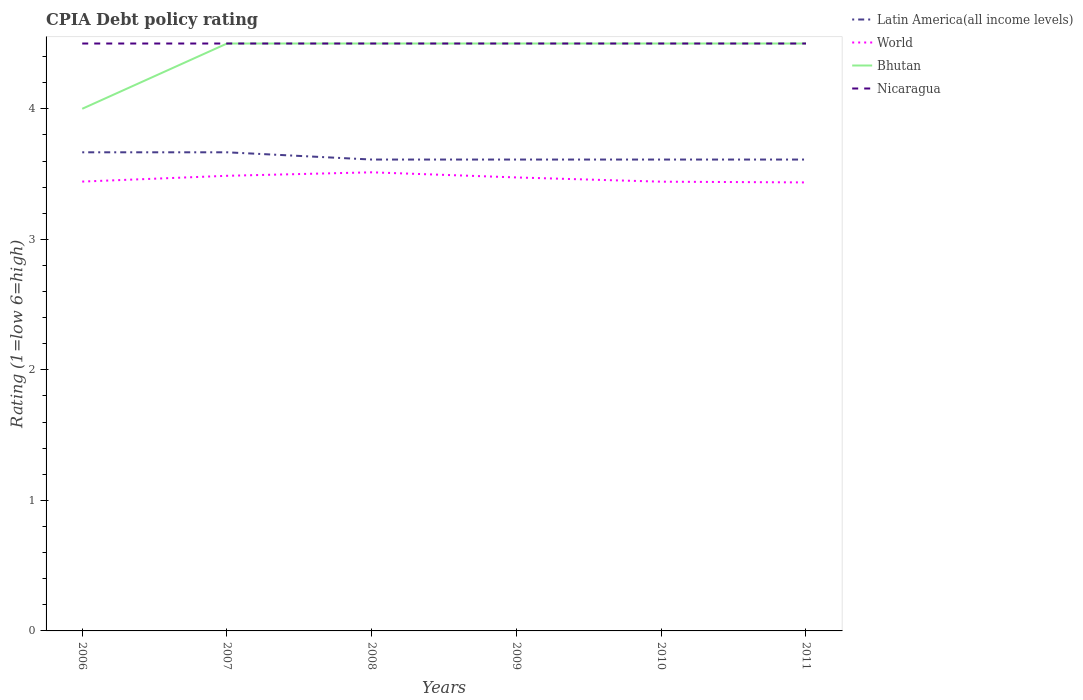Across all years, what is the maximum CPIA rating in Latin America(all income levels)?
Offer a terse response. 3.61. Is the CPIA rating in Latin America(all income levels) strictly greater than the CPIA rating in World over the years?
Keep it short and to the point. No. Does the graph contain any zero values?
Keep it short and to the point. No. How many legend labels are there?
Offer a very short reply. 4. How are the legend labels stacked?
Make the answer very short. Vertical. What is the title of the graph?
Offer a terse response. CPIA Debt policy rating. Does "Puerto Rico" appear as one of the legend labels in the graph?
Your answer should be compact. No. What is the label or title of the Y-axis?
Make the answer very short. Rating (1=low 6=high). What is the Rating (1=low 6=high) of Latin America(all income levels) in 2006?
Offer a very short reply. 3.67. What is the Rating (1=low 6=high) in World in 2006?
Make the answer very short. 3.44. What is the Rating (1=low 6=high) of Latin America(all income levels) in 2007?
Your answer should be very brief. 3.67. What is the Rating (1=low 6=high) in World in 2007?
Offer a terse response. 3.49. What is the Rating (1=low 6=high) of Bhutan in 2007?
Your response must be concise. 4.5. What is the Rating (1=low 6=high) of Nicaragua in 2007?
Your answer should be compact. 4.5. What is the Rating (1=low 6=high) in Latin America(all income levels) in 2008?
Your response must be concise. 3.61. What is the Rating (1=low 6=high) in World in 2008?
Offer a terse response. 3.51. What is the Rating (1=low 6=high) in Bhutan in 2008?
Offer a terse response. 4.5. What is the Rating (1=low 6=high) of Latin America(all income levels) in 2009?
Give a very brief answer. 3.61. What is the Rating (1=low 6=high) in World in 2009?
Your answer should be very brief. 3.47. What is the Rating (1=low 6=high) of Latin America(all income levels) in 2010?
Your answer should be compact. 3.61. What is the Rating (1=low 6=high) of World in 2010?
Your answer should be very brief. 3.44. What is the Rating (1=low 6=high) of Bhutan in 2010?
Keep it short and to the point. 4.5. What is the Rating (1=low 6=high) in Nicaragua in 2010?
Make the answer very short. 4.5. What is the Rating (1=low 6=high) of Latin America(all income levels) in 2011?
Give a very brief answer. 3.61. What is the Rating (1=low 6=high) of World in 2011?
Keep it short and to the point. 3.44. What is the Rating (1=low 6=high) of Bhutan in 2011?
Offer a very short reply. 4.5. What is the Rating (1=low 6=high) in Nicaragua in 2011?
Ensure brevity in your answer.  4.5. Across all years, what is the maximum Rating (1=low 6=high) of Latin America(all income levels)?
Give a very brief answer. 3.67. Across all years, what is the maximum Rating (1=low 6=high) in World?
Your response must be concise. 3.51. Across all years, what is the maximum Rating (1=low 6=high) of Bhutan?
Your answer should be very brief. 4.5. Across all years, what is the maximum Rating (1=low 6=high) of Nicaragua?
Offer a very short reply. 4.5. Across all years, what is the minimum Rating (1=low 6=high) in Latin America(all income levels)?
Provide a short and direct response. 3.61. Across all years, what is the minimum Rating (1=low 6=high) of World?
Your response must be concise. 3.44. Across all years, what is the minimum Rating (1=low 6=high) of Nicaragua?
Provide a succinct answer. 4.5. What is the total Rating (1=low 6=high) in Latin America(all income levels) in the graph?
Your answer should be very brief. 21.78. What is the total Rating (1=low 6=high) of World in the graph?
Make the answer very short. 20.79. What is the difference between the Rating (1=low 6=high) of Latin America(all income levels) in 2006 and that in 2007?
Your answer should be very brief. 0. What is the difference between the Rating (1=low 6=high) of World in 2006 and that in 2007?
Offer a very short reply. -0.04. What is the difference between the Rating (1=low 6=high) of Latin America(all income levels) in 2006 and that in 2008?
Provide a short and direct response. 0.06. What is the difference between the Rating (1=low 6=high) of World in 2006 and that in 2008?
Keep it short and to the point. -0.07. What is the difference between the Rating (1=low 6=high) in Nicaragua in 2006 and that in 2008?
Offer a very short reply. 0. What is the difference between the Rating (1=low 6=high) of Latin America(all income levels) in 2006 and that in 2009?
Your answer should be very brief. 0.06. What is the difference between the Rating (1=low 6=high) of World in 2006 and that in 2009?
Ensure brevity in your answer.  -0.03. What is the difference between the Rating (1=low 6=high) of Bhutan in 2006 and that in 2009?
Offer a terse response. -0.5. What is the difference between the Rating (1=low 6=high) of Nicaragua in 2006 and that in 2009?
Make the answer very short. 0. What is the difference between the Rating (1=low 6=high) in Latin America(all income levels) in 2006 and that in 2010?
Offer a terse response. 0.06. What is the difference between the Rating (1=low 6=high) in World in 2006 and that in 2010?
Your answer should be very brief. 0. What is the difference between the Rating (1=low 6=high) of Latin America(all income levels) in 2006 and that in 2011?
Offer a terse response. 0.06. What is the difference between the Rating (1=low 6=high) in World in 2006 and that in 2011?
Keep it short and to the point. 0.01. What is the difference between the Rating (1=low 6=high) of Latin America(all income levels) in 2007 and that in 2008?
Provide a succinct answer. 0.06. What is the difference between the Rating (1=low 6=high) in World in 2007 and that in 2008?
Give a very brief answer. -0.03. What is the difference between the Rating (1=low 6=high) of Bhutan in 2007 and that in 2008?
Your answer should be very brief. 0. What is the difference between the Rating (1=low 6=high) of Latin America(all income levels) in 2007 and that in 2009?
Make the answer very short. 0.06. What is the difference between the Rating (1=low 6=high) in World in 2007 and that in 2009?
Your response must be concise. 0.01. What is the difference between the Rating (1=low 6=high) of Bhutan in 2007 and that in 2009?
Make the answer very short. 0. What is the difference between the Rating (1=low 6=high) of Latin America(all income levels) in 2007 and that in 2010?
Ensure brevity in your answer.  0.06. What is the difference between the Rating (1=low 6=high) in World in 2007 and that in 2010?
Make the answer very short. 0.05. What is the difference between the Rating (1=low 6=high) in Nicaragua in 2007 and that in 2010?
Your answer should be compact. 0. What is the difference between the Rating (1=low 6=high) in Latin America(all income levels) in 2007 and that in 2011?
Your answer should be compact. 0.06. What is the difference between the Rating (1=low 6=high) of World in 2007 and that in 2011?
Make the answer very short. 0.05. What is the difference between the Rating (1=low 6=high) of Bhutan in 2007 and that in 2011?
Provide a succinct answer. 0. What is the difference between the Rating (1=low 6=high) of Nicaragua in 2007 and that in 2011?
Your response must be concise. 0. What is the difference between the Rating (1=low 6=high) of World in 2008 and that in 2009?
Your answer should be compact. 0.04. What is the difference between the Rating (1=low 6=high) in Bhutan in 2008 and that in 2009?
Your response must be concise. 0. What is the difference between the Rating (1=low 6=high) in Latin America(all income levels) in 2008 and that in 2010?
Ensure brevity in your answer.  0. What is the difference between the Rating (1=low 6=high) in World in 2008 and that in 2010?
Keep it short and to the point. 0.07. What is the difference between the Rating (1=low 6=high) in Bhutan in 2008 and that in 2010?
Your answer should be very brief. 0. What is the difference between the Rating (1=low 6=high) of Latin America(all income levels) in 2008 and that in 2011?
Your response must be concise. 0. What is the difference between the Rating (1=low 6=high) of World in 2008 and that in 2011?
Give a very brief answer. 0.08. What is the difference between the Rating (1=low 6=high) of Nicaragua in 2008 and that in 2011?
Give a very brief answer. 0. What is the difference between the Rating (1=low 6=high) of Latin America(all income levels) in 2009 and that in 2010?
Provide a succinct answer. 0. What is the difference between the Rating (1=low 6=high) of World in 2009 and that in 2010?
Provide a short and direct response. 0.03. What is the difference between the Rating (1=low 6=high) of Latin America(all income levels) in 2009 and that in 2011?
Give a very brief answer. 0. What is the difference between the Rating (1=low 6=high) in World in 2009 and that in 2011?
Your answer should be compact. 0.04. What is the difference between the Rating (1=low 6=high) of Nicaragua in 2009 and that in 2011?
Provide a short and direct response. 0. What is the difference between the Rating (1=low 6=high) of World in 2010 and that in 2011?
Your answer should be very brief. 0.01. What is the difference between the Rating (1=low 6=high) of Bhutan in 2010 and that in 2011?
Offer a very short reply. 0. What is the difference between the Rating (1=low 6=high) of Latin America(all income levels) in 2006 and the Rating (1=low 6=high) of World in 2007?
Offer a terse response. 0.18. What is the difference between the Rating (1=low 6=high) of Latin America(all income levels) in 2006 and the Rating (1=low 6=high) of Bhutan in 2007?
Give a very brief answer. -0.83. What is the difference between the Rating (1=low 6=high) of World in 2006 and the Rating (1=low 6=high) of Bhutan in 2007?
Ensure brevity in your answer.  -1.06. What is the difference between the Rating (1=low 6=high) of World in 2006 and the Rating (1=low 6=high) of Nicaragua in 2007?
Your answer should be very brief. -1.06. What is the difference between the Rating (1=low 6=high) of Bhutan in 2006 and the Rating (1=low 6=high) of Nicaragua in 2007?
Provide a short and direct response. -0.5. What is the difference between the Rating (1=low 6=high) in Latin America(all income levels) in 2006 and the Rating (1=low 6=high) in World in 2008?
Ensure brevity in your answer.  0.15. What is the difference between the Rating (1=low 6=high) in Latin America(all income levels) in 2006 and the Rating (1=low 6=high) in Bhutan in 2008?
Keep it short and to the point. -0.83. What is the difference between the Rating (1=low 6=high) of Latin America(all income levels) in 2006 and the Rating (1=low 6=high) of Nicaragua in 2008?
Ensure brevity in your answer.  -0.83. What is the difference between the Rating (1=low 6=high) of World in 2006 and the Rating (1=low 6=high) of Bhutan in 2008?
Offer a very short reply. -1.06. What is the difference between the Rating (1=low 6=high) in World in 2006 and the Rating (1=low 6=high) in Nicaragua in 2008?
Keep it short and to the point. -1.06. What is the difference between the Rating (1=low 6=high) of Bhutan in 2006 and the Rating (1=low 6=high) of Nicaragua in 2008?
Offer a terse response. -0.5. What is the difference between the Rating (1=low 6=high) in Latin America(all income levels) in 2006 and the Rating (1=low 6=high) in World in 2009?
Keep it short and to the point. 0.19. What is the difference between the Rating (1=low 6=high) of Latin America(all income levels) in 2006 and the Rating (1=low 6=high) of Nicaragua in 2009?
Your answer should be very brief. -0.83. What is the difference between the Rating (1=low 6=high) in World in 2006 and the Rating (1=low 6=high) in Bhutan in 2009?
Keep it short and to the point. -1.06. What is the difference between the Rating (1=low 6=high) in World in 2006 and the Rating (1=low 6=high) in Nicaragua in 2009?
Make the answer very short. -1.06. What is the difference between the Rating (1=low 6=high) in Bhutan in 2006 and the Rating (1=low 6=high) in Nicaragua in 2009?
Make the answer very short. -0.5. What is the difference between the Rating (1=low 6=high) in Latin America(all income levels) in 2006 and the Rating (1=low 6=high) in World in 2010?
Your answer should be compact. 0.23. What is the difference between the Rating (1=low 6=high) in Latin America(all income levels) in 2006 and the Rating (1=low 6=high) in Bhutan in 2010?
Offer a terse response. -0.83. What is the difference between the Rating (1=low 6=high) of Latin America(all income levels) in 2006 and the Rating (1=low 6=high) of Nicaragua in 2010?
Offer a very short reply. -0.83. What is the difference between the Rating (1=low 6=high) of World in 2006 and the Rating (1=low 6=high) of Bhutan in 2010?
Your response must be concise. -1.06. What is the difference between the Rating (1=low 6=high) of World in 2006 and the Rating (1=low 6=high) of Nicaragua in 2010?
Make the answer very short. -1.06. What is the difference between the Rating (1=low 6=high) of Latin America(all income levels) in 2006 and the Rating (1=low 6=high) of World in 2011?
Your answer should be very brief. 0.23. What is the difference between the Rating (1=low 6=high) in Latin America(all income levels) in 2006 and the Rating (1=low 6=high) in Bhutan in 2011?
Make the answer very short. -0.83. What is the difference between the Rating (1=low 6=high) of World in 2006 and the Rating (1=low 6=high) of Bhutan in 2011?
Your answer should be compact. -1.06. What is the difference between the Rating (1=low 6=high) of World in 2006 and the Rating (1=low 6=high) of Nicaragua in 2011?
Your response must be concise. -1.06. What is the difference between the Rating (1=low 6=high) in Latin America(all income levels) in 2007 and the Rating (1=low 6=high) in World in 2008?
Ensure brevity in your answer.  0.15. What is the difference between the Rating (1=low 6=high) in Latin America(all income levels) in 2007 and the Rating (1=low 6=high) in Bhutan in 2008?
Provide a succinct answer. -0.83. What is the difference between the Rating (1=low 6=high) in World in 2007 and the Rating (1=low 6=high) in Bhutan in 2008?
Your answer should be very brief. -1.01. What is the difference between the Rating (1=low 6=high) in World in 2007 and the Rating (1=low 6=high) in Nicaragua in 2008?
Ensure brevity in your answer.  -1.01. What is the difference between the Rating (1=low 6=high) in Bhutan in 2007 and the Rating (1=low 6=high) in Nicaragua in 2008?
Offer a terse response. 0. What is the difference between the Rating (1=low 6=high) of Latin America(all income levels) in 2007 and the Rating (1=low 6=high) of World in 2009?
Your answer should be very brief. 0.19. What is the difference between the Rating (1=low 6=high) in Latin America(all income levels) in 2007 and the Rating (1=low 6=high) in Nicaragua in 2009?
Make the answer very short. -0.83. What is the difference between the Rating (1=low 6=high) of World in 2007 and the Rating (1=low 6=high) of Bhutan in 2009?
Keep it short and to the point. -1.01. What is the difference between the Rating (1=low 6=high) in World in 2007 and the Rating (1=low 6=high) in Nicaragua in 2009?
Offer a terse response. -1.01. What is the difference between the Rating (1=low 6=high) of Bhutan in 2007 and the Rating (1=low 6=high) of Nicaragua in 2009?
Make the answer very short. 0. What is the difference between the Rating (1=low 6=high) of Latin America(all income levels) in 2007 and the Rating (1=low 6=high) of World in 2010?
Your answer should be very brief. 0.23. What is the difference between the Rating (1=low 6=high) in Latin America(all income levels) in 2007 and the Rating (1=low 6=high) in Bhutan in 2010?
Your response must be concise. -0.83. What is the difference between the Rating (1=low 6=high) in Latin America(all income levels) in 2007 and the Rating (1=low 6=high) in Nicaragua in 2010?
Your response must be concise. -0.83. What is the difference between the Rating (1=low 6=high) of World in 2007 and the Rating (1=low 6=high) of Bhutan in 2010?
Give a very brief answer. -1.01. What is the difference between the Rating (1=low 6=high) of World in 2007 and the Rating (1=low 6=high) of Nicaragua in 2010?
Offer a terse response. -1.01. What is the difference between the Rating (1=low 6=high) in Bhutan in 2007 and the Rating (1=low 6=high) in Nicaragua in 2010?
Offer a very short reply. 0. What is the difference between the Rating (1=low 6=high) in Latin America(all income levels) in 2007 and the Rating (1=low 6=high) in World in 2011?
Ensure brevity in your answer.  0.23. What is the difference between the Rating (1=low 6=high) of Latin America(all income levels) in 2007 and the Rating (1=low 6=high) of Bhutan in 2011?
Your answer should be very brief. -0.83. What is the difference between the Rating (1=low 6=high) of Latin America(all income levels) in 2007 and the Rating (1=low 6=high) of Nicaragua in 2011?
Provide a succinct answer. -0.83. What is the difference between the Rating (1=low 6=high) of World in 2007 and the Rating (1=low 6=high) of Bhutan in 2011?
Keep it short and to the point. -1.01. What is the difference between the Rating (1=low 6=high) of World in 2007 and the Rating (1=low 6=high) of Nicaragua in 2011?
Keep it short and to the point. -1.01. What is the difference between the Rating (1=low 6=high) in Latin America(all income levels) in 2008 and the Rating (1=low 6=high) in World in 2009?
Keep it short and to the point. 0.14. What is the difference between the Rating (1=low 6=high) of Latin America(all income levels) in 2008 and the Rating (1=low 6=high) of Bhutan in 2009?
Your response must be concise. -0.89. What is the difference between the Rating (1=low 6=high) in Latin America(all income levels) in 2008 and the Rating (1=low 6=high) in Nicaragua in 2009?
Your response must be concise. -0.89. What is the difference between the Rating (1=low 6=high) of World in 2008 and the Rating (1=low 6=high) of Bhutan in 2009?
Make the answer very short. -0.99. What is the difference between the Rating (1=low 6=high) in World in 2008 and the Rating (1=low 6=high) in Nicaragua in 2009?
Ensure brevity in your answer.  -0.99. What is the difference between the Rating (1=low 6=high) of Bhutan in 2008 and the Rating (1=low 6=high) of Nicaragua in 2009?
Ensure brevity in your answer.  0. What is the difference between the Rating (1=low 6=high) in Latin America(all income levels) in 2008 and the Rating (1=low 6=high) in World in 2010?
Offer a terse response. 0.17. What is the difference between the Rating (1=low 6=high) of Latin America(all income levels) in 2008 and the Rating (1=low 6=high) of Bhutan in 2010?
Make the answer very short. -0.89. What is the difference between the Rating (1=low 6=high) in Latin America(all income levels) in 2008 and the Rating (1=low 6=high) in Nicaragua in 2010?
Ensure brevity in your answer.  -0.89. What is the difference between the Rating (1=low 6=high) of World in 2008 and the Rating (1=low 6=high) of Bhutan in 2010?
Your answer should be compact. -0.99. What is the difference between the Rating (1=low 6=high) in World in 2008 and the Rating (1=low 6=high) in Nicaragua in 2010?
Offer a very short reply. -0.99. What is the difference between the Rating (1=low 6=high) of Bhutan in 2008 and the Rating (1=low 6=high) of Nicaragua in 2010?
Provide a short and direct response. 0. What is the difference between the Rating (1=low 6=high) of Latin America(all income levels) in 2008 and the Rating (1=low 6=high) of World in 2011?
Offer a terse response. 0.18. What is the difference between the Rating (1=low 6=high) in Latin America(all income levels) in 2008 and the Rating (1=low 6=high) in Bhutan in 2011?
Keep it short and to the point. -0.89. What is the difference between the Rating (1=low 6=high) of Latin America(all income levels) in 2008 and the Rating (1=low 6=high) of Nicaragua in 2011?
Ensure brevity in your answer.  -0.89. What is the difference between the Rating (1=low 6=high) in World in 2008 and the Rating (1=low 6=high) in Bhutan in 2011?
Your answer should be very brief. -0.99. What is the difference between the Rating (1=low 6=high) of World in 2008 and the Rating (1=low 6=high) of Nicaragua in 2011?
Make the answer very short. -0.99. What is the difference between the Rating (1=low 6=high) in Bhutan in 2008 and the Rating (1=low 6=high) in Nicaragua in 2011?
Make the answer very short. 0. What is the difference between the Rating (1=low 6=high) in Latin America(all income levels) in 2009 and the Rating (1=low 6=high) in World in 2010?
Make the answer very short. 0.17. What is the difference between the Rating (1=low 6=high) in Latin America(all income levels) in 2009 and the Rating (1=low 6=high) in Bhutan in 2010?
Make the answer very short. -0.89. What is the difference between the Rating (1=low 6=high) of Latin America(all income levels) in 2009 and the Rating (1=low 6=high) of Nicaragua in 2010?
Keep it short and to the point. -0.89. What is the difference between the Rating (1=low 6=high) of World in 2009 and the Rating (1=low 6=high) of Bhutan in 2010?
Keep it short and to the point. -1.03. What is the difference between the Rating (1=low 6=high) of World in 2009 and the Rating (1=low 6=high) of Nicaragua in 2010?
Keep it short and to the point. -1.03. What is the difference between the Rating (1=low 6=high) in Bhutan in 2009 and the Rating (1=low 6=high) in Nicaragua in 2010?
Offer a terse response. 0. What is the difference between the Rating (1=low 6=high) of Latin America(all income levels) in 2009 and the Rating (1=low 6=high) of World in 2011?
Ensure brevity in your answer.  0.18. What is the difference between the Rating (1=low 6=high) of Latin America(all income levels) in 2009 and the Rating (1=low 6=high) of Bhutan in 2011?
Offer a very short reply. -0.89. What is the difference between the Rating (1=low 6=high) of Latin America(all income levels) in 2009 and the Rating (1=low 6=high) of Nicaragua in 2011?
Make the answer very short. -0.89. What is the difference between the Rating (1=low 6=high) of World in 2009 and the Rating (1=low 6=high) of Bhutan in 2011?
Your answer should be very brief. -1.03. What is the difference between the Rating (1=low 6=high) in World in 2009 and the Rating (1=low 6=high) in Nicaragua in 2011?
Your answer should be compact. -1.03. What is the difference between the Rating (1=low 6=high) in Latin America(all income levels) in 2010 and the Rating (1=low 6=high) in World in 2011?
Make the answer very short. 0.18. What is the difference between the Rating (1=low 6=high) in Latin America(all income levels) in 2010 and the Rating (1=low 6=high) in Bhutan in 2011?
Your answer should be very brief. -0.89. What is the difference between the Rating (1=low 6=high) in Latin America(all income levels) in 2010 and the Rating (1=low 6=high) in Nicaragua in 2011?
Your response must be concise. -0.89. What is the difference between the Rating (1=low 6=high) of World in 2010 and the Rating (1=low 6=high) of Bhutan in 2011?
Keep it short and to the point. -1.06. What is the difference between the Rating (1=low 6=high) of World in 2010 and the Rating (1=low 6=high) of Nicaragua in 2011?
Offer a very short reply. -1.06. What is the average Rating (1=low 6=high) of Latin America(all income levels) per year?
Give a very brief answer. 3.63. What is the average Rating (1=low 6=high) in World per year?
Offer a terse response. 3.47. What is the average Rating (1=low 6=high) in Bhutan per year?
Ensure brevity in your answer.  4.42. What is the average Rating (1=low 6=high) in Nicaragua per year?
Provide a short and direct response. 4.5. In the year 2006, what is the difference between the Rating (1=low 6=high) in Latin America(all income levels) and Rating (1=low 6=high) in World?
Offer a very short reply. 0.22. In the year 2006, what is the difference between the Rating (1=low 6=high) in World and Rating (1=low 6=high) in Bhutan?
Your answer should be very brief. -0.56. In the year 2006, what is the difference between the Rating (1=low 6=high) of World and Rating (1=low 6=high) of Nicaragua?
Offer a terse response. -1.06. In the year 2006, what is the difference between the Rating (1=low 6=high) in Bhutan and Rating (1=low 6=high) in Nicaragua?
Provide a succinct answer. -0.5. In the year 2007, what is the difference between the Rating (1=low 6=high) of Latin America(all income levels) and Rating (1=low 6=high) of World?
Provide a short and direct response. 0.18. In the year 2007, what is the difference between the Rating (1=low 6=high) in Latin America(all income levels) and Rating (1=low 6=high) in Bhutan?
Keep it short and to the point. -0.83. In the year 2007, what is the difference between the Rating (1=low 6=high) in World and Rating (1=low 6=high) in Bhutan?
Offer a very short reply. -1.01. In the year 2007, what is the difference between the Rating (1=low 6=high) of World and Rating (1=low 6=high) of Nicaragua?
Offer a terse response. -1.01. In the year 2007, what is the difference between the Rating (1=low 6=high) of Bhutan and Rating (1=low 6=high) of Nicaragua?
Provide a succinct answer. 0. In the year 2008, what is the difference between the Rating (1=low 6=high) of Latin America(all income levels) and Rating (1=low 6=high) of World?
Ensure brevity in your answer.  0.1. In the year 2008, what is the difference between the Rating (1=low 6=high) of Latin America(all income levels) and Rating (1=low 6=high) of Bhutan?
Keep it short and to the point. -0.89. In the year 2008, what is the difference between the Rating (1=low 6=high) of Latin America(all income levels) and Rating (1=low 6=high) of Nicaragua?
Your answer should be compact. -0.89. In the year 2008, what is the difference between the Rating (1=low 6=high) of World and Rating (1=low 6=high) of Bhutan?
Give a very brief answer. -0.99. In the year 2008, what is the difference between the Rating (1=low 6=high) in World and Rating (1=low 6=high) in Nicaragua?
Offer a very short reply. -0.99. In the year 2009, what is the difference between the Rating (1=low 6=high) of Latin America(all income levels) and Rating (1=low 6=high) of World?
Make the answer very short. 0.14. In the year 2009, what is the difference between the Rating (1=low 6=high) of Latin America(all income levels) and Rating (1=low 6=high) of Bhutan?
Give a very brief answer. -0.89. In the year 2009, what is the difference between the Rating (1=low 6=high) in Latin America(all income levels) and Rating (1=low 6=high) in Nicaragua?
Provide a succinct answer. -0.89. In the year 2009, what is the difference between the Rating (1=low 6=high) in World and Rating (1=low 6=high) in Bhutan?
Make the answer very short. -1.03. In the year 2009, what is the difference between the Rating (1=low 6=high) of World and Rating (1=low 6=high) of Nicaragua?
Provide a short and direct response. -1.03. In the year 2009, what is the difference between the Rating (1=low 6=high) of Bhutan and Rating (1=low 6=high) of Nicaragua?
Give a very brief answer. 0. In the year 2010, what is the difference between the Rating (1=low 6=high) of Latin America(all income levels) and Rating (1=low 6=high) of World?
Offer a terse response. 0.17. In the year 2010, what is the difference between the Rating (1=low 6=high) in Latin America(all income levels) and Rating (1=low 6=high) in Bhutan?
Ensure brevity in your answer.  -0.89. In the year 2010, what is the difference between the Rating (1=low 6=high) in Latin America(all income levels) and Rating (1=low 6=high) in Nicaragua?
Your answer should be compact. -0.89. In the year 2010, what is the difference between the Rating (1=low 6=high) in World and Rating (1=low 6=high) in Bhutan?
Ensure brevity in your answer.  -1.06. In the year 2010, what is the difference between the Rating (1=low 6=high) of World and Rating (1=low 6=high) of Nicaragua?
Your answer should be very brief. -1.06. In the year 2010, what is the difference between the Rating (1=low 6=high) of Bhutan and Rating (1=low 6=high) of Nicaragua?
Your answer should be very brief. 0. In the year 2011, what is the difference between the Rating (1=low 6=high) in Latin America(all income levels) and Rating (1=low 6=high) in World?
Your response must be concise. 0.18. In the year 2011, what is the difference between the Rating (1=low 6=high) in Latin America(all income levels) and Rating (1=low 6=high) in Bhutan?
Your response must be concise. -0.89. In the year 2011, what is the difference between the Rating (1=low 6=high) in Latin America(all income levels) and Rating (1=low 6=high) in Nicaragua?
Ensure brevity in your answer.  -0.89. In the year 2011, what is the difference between the Rating (1=low 6=high) of World and Rating (1=low 6=high) of Bhutan?
Provide a short and direct response. -1.06. In the year 2011, what is the difference between the Rating (1=low 6=high) of World and Rating (1=low 6=high) of Nicaragua?
Offer a terse response. -1.06. What is the ratio of the Rating (1=low 6=high) in World in 2006 to that in 2007?
Provide a succinct answer. 0.99. What is the ratio of the Rating (1=low 6=high) in Latin America(all income levels) in 2006 to that in 2008?
Give a very brief answer. 1.02. What is the ratio of the Rating (1=low 6=high) of World in 2006 to that in 2008?
Ensure brevity in your answer.  0.98. What is the ratio of the Rating (1=low 6=high) in Nicaragua in 2006 to that in 2008?
Give a very brief answer. 1. What is the ratio of the Rating (1=low 6=high) in Latin America(all income levels) in 2006 to that in 2009?
Keep it short and to the point. 1.02. What is the ratio of the Rating (1=low 6=high) of World in 2006 to that in 2009?
Your response must be concise. 0.99. What is the ratio of the Rating (1=low 6=high) in Bhutan in 2006 to that in 2009?
Give a very brief answer. 0.89. What is the ratio of the Rating (1=low 6=high) of Latin America(all income levels) in 2006 to that in 2010?
Your answer should be compact. 1.02. What is the ratio of the Rating (1=low 6=high) of World in 2006 to that in 2010?
Offer a very short reply. 1. What is the ratio of the Rating (1=low 6=high) of Latin America(all income levels) in 2006 to that in 2011?
Provide a succinct answer. 1.02. What is the ratio of the Rating (1=low 6=high) of Bhutan in 2006 to that in 2011?
Offer a very short reply. 0.89. What is the ratio of the Rating (1=low 6=high) of Latin America(all income levels) in 2007 to that in 2008?
Your answer should be compact. 1.02. What is the ratio of the Rating (1=low 6=high) of Bhutan in 2007 to that in 2008?
Your answer should be compact. 1. What is the ratio of the Rating (1=low 6=high) in Latin America(all income levels) in 2007 to that in 2009?
Your answer should be compact. 1.02. What is the ratio of the Rating (1=low 6=high) in World in 2007 to that in 2009?
Your answer should be compact. 1. What is the ratio of the Rating (1=low 6=high) in Latin America(all income levels) in 2007 to that in 2010?
Your answer should be compact. 1.02. What is the ratio of the Rating (1=low 6=high) of World in 2007 to that in 2010?
Provide a short and direct response. 1.01. What is the ratio of the Rating (1=low 6=high) of Nicaragua in 2007 to that in 2010?
Provide a short and direct response. 1. What is the ratio of the Rating (1=low 6=high) of Latin America(all income levels) in 2007 to that in 2011?
Your answer should be compact. 1.02. What is the ratio of the Rating (1=low 6=high) of World in 2007 to that in 2011?
Make the answer very short. 1.01. What is the ratio of the Rating (1=low 6=high) in World in 2008 to that in 2009?
Offer a terse response. 1.01. What is the ratio of the Rating (1=low 6=high) in Bhutan in 2008 to that in 2009?
Your response must be concise. 1. What is the ratio of the Rating (1=low 6=high) of Nicaragua in 2008 to that in 2009?
Keep it short and to the point. 1. What is the ratio of the Rating (1=low 6=high) in World in 2008 to that in 2010?
Offer a terse response. 1.02. What is the ratio of the Rating (1=low 6=high) of Bhutan in 2008 to that in 2010?
Ensure brevity in your answer.  1. What is the ratio of the Rating (1=low 6=high) of Latin America(all income levels) in 2008 to that in 2011?
Make the answer very short. 1. What is the ratio of the Rating (1=low 6=high) in World in 2008 to that in 2011?
Your answer should be compact. 1.02. What is the ratio of the Rating (1=low 6=high) in Bhutan in 2008 to that in 2011?
Your answer should be very brief. 1. What is the ratio of the Rating (1=low 6=high) in Nicaragua in 2008 to that in 2011?
Your answer should be very brief. 1. What is the ratio of the Rating (1=low 6=high) of Latin America(all income levels) in 2009 to that in 2010?
Your response must be concise. 1. What is the ratio of the Rating (1=low 6=high) in World in 2009 to that in 2010?
Make the answer very short. 1.01. What is the ratio of the Rating (1=low 6=high) of Latin America(all income levels) in 2009 to that in 2011?
Provide a short and direct response. 1. What is the ratio of the Rating (1=low 6=high) of World in 2009 to that in 2011?
Provide a short and direct response. 1.01. What is the ratio of the Rating (1=low 6=high) of World in 2010 to that in 2011?
Offer a very short reply. 1. What is the ratio of the Rating (1=low 6=high) of Nicaragua in 2010 to that in 2011?
Your answer should be very brief. 1. What is the difference between the highest and the second highest Rating (1=low 6=high) of World?
Your response must be concise. 0.03. What is the difference between the highest and the second highest Rating (1=low 6=high) in Bhutan?
Ensure brevity in your answer.  0. What is the difference between the highest and the lowest Rating (1=low 6=high) of Latin America(all income levels)?
Make the answer very short. 0.06. What is the difference between the highest and the lowest Rating (1=low 6=high) of World?
Keep it short and to the point. 0.08. What is the difference between the highest and the lowest Rating (1=low 6=high) in Nicaragua?
Provide a short and direct response. 0. 